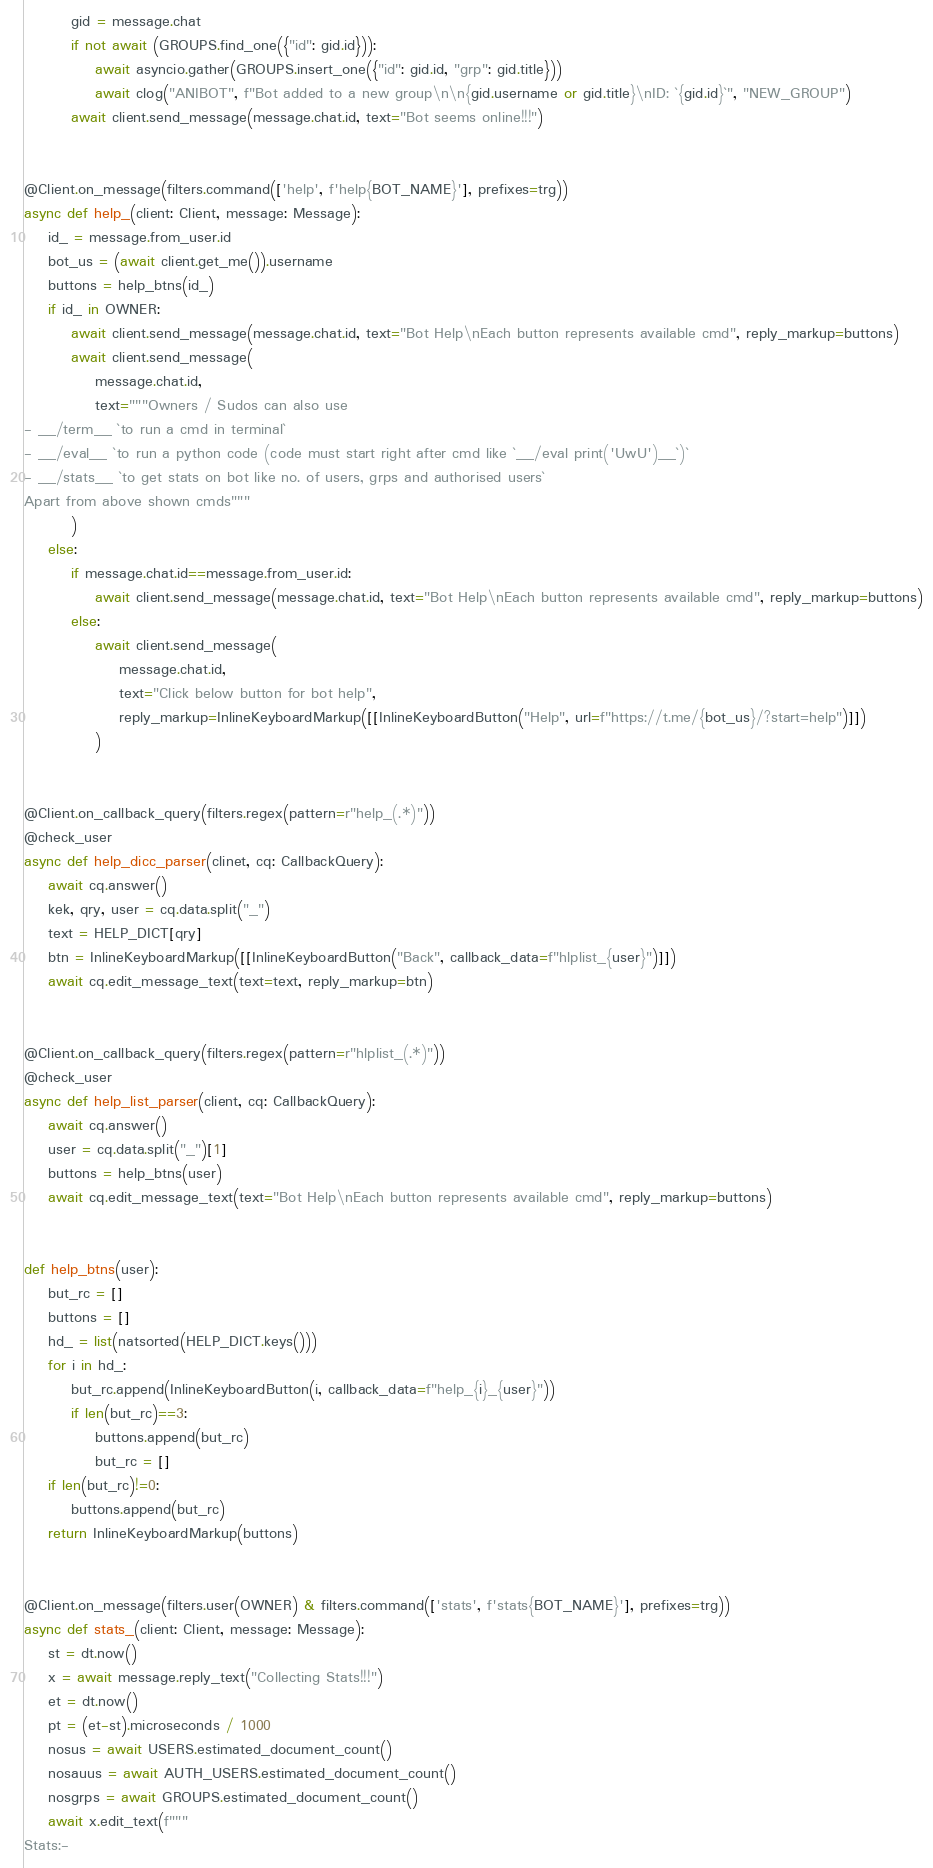<code> <loc_0><loc_0><loc_500><loc_500><_Python_>        gid = message.chat
        if not await (GROUPS.find_one({"id": gid.id})):
            await asyncio.gather(GROUPS.insert_one({"id": gid.id, "grp": gid.title}))
            await clog("ANIBOT", f"Bot added to a new group\n\n{gid.username or gid.title}\nID: `{gid.id}`", "NEW_GROUP")
        await client.send_message(message.chat.id, text="Bot seems online!!!")


@Client.on_message(filters.command(['help', f'help{BOT_NAME}'], prefixes=trg))
async def help_(client: Client, message: Message):
    id_ = message.from_user.id
    bot_us = (await client.get_me()).username
    buttons = help_btns(id_)
    if id_ in OWNER:
        await client.send_message(message.chat.id, text="Bot Help\nEach button represents available cmd", reply_markup=buttons)
        await client.send_message(
            message.chat.id,
            text="""Owners / Sudos can also use
- __/term__ `to run a cmd in terminal`
- __/eval__ `to run a python code (code must start right after cmd like `__/eval print('UwU')__`)`
- __/stats__ `to get stats on bot like no. of users, grps and authorised users`
Apart from above shown cmds"""
        )
    else:
        if message.chat.id==message.from_user.id:
            await client.send_message(message.chat.id, text="Bot Help\nEach button represents available cmd", reply_markup=buttons)
        else:
            await client.send_message(
                message.chat.id,
                text="Click below button for bot help",
                reply_markup=InlineKeyboardMarkup([[InlineKeyboardButton("Help", url=f"https://t.me/{bot_us}/?start=help")]])
            )


@Client.on_callback_query(filters.regex(pattern=r"help_(.*)"))
@check_user
async def help_dicc_parser(clinet, cq: CallbackQuery):
    await cq.answer()
    kek, qry, user = cq.data.split("_")
    text = HELP_DICT[qry]
    btn = InlineKeyboardMarkup([[InlineKeyboardButton("Back", callback_data=f"hlplist_{user}")]])
    await cq.edit_message_text(text=text, reply_markup=btn)


@Client.on_callback_query(filters.regex(pattern=r"hlplist_(.*)"))
@check_user
async def help_list_parser(client, cq: CallbackQuery):
    await cq.answer()
    user = cq.data.split("_")[1]
    buttons = help_btns(user)
    await cq.edit_message_text(text="Bot Help\nEach button represents available cmd", reply_markup=buttons)


def help_btns(user):
    but_rc = []
    buttons = []
    hd_ = list(natsorted(HELP_DICT.keys()))
    for i in hd_:
        but_rc.append(InlineKeyboardButton(i, callback_data=f"help_{i}_{user}"))
        if len(but_rc)==3:
            buttons.append(but_rc)
            but_rc = []
    if len(but_rc)!=0:
        buttons.append(but_rc)
    return InlineKeyboardMarkup(buttons)


@Client.on_message(filters.user(OWNER) & filters.command(['stats', f'stats{BOT_NAME}'], prefixes=trg))
async def stats_(client: Client, message: Message):
    st = dt.now()
    x = await message.reply_text("Collecting Stats!!!")
    et = dt.now()
    pt = (et-st).microseconds / 1000
    nosus = await USERS.estimated_document_count()
    nosauus = await AUTH_USERS.estimated_document_count()
    nosgrps = await GROUPS.estimated_document_count()
    await x.edit_text(f"""
Stats:-
</code> 